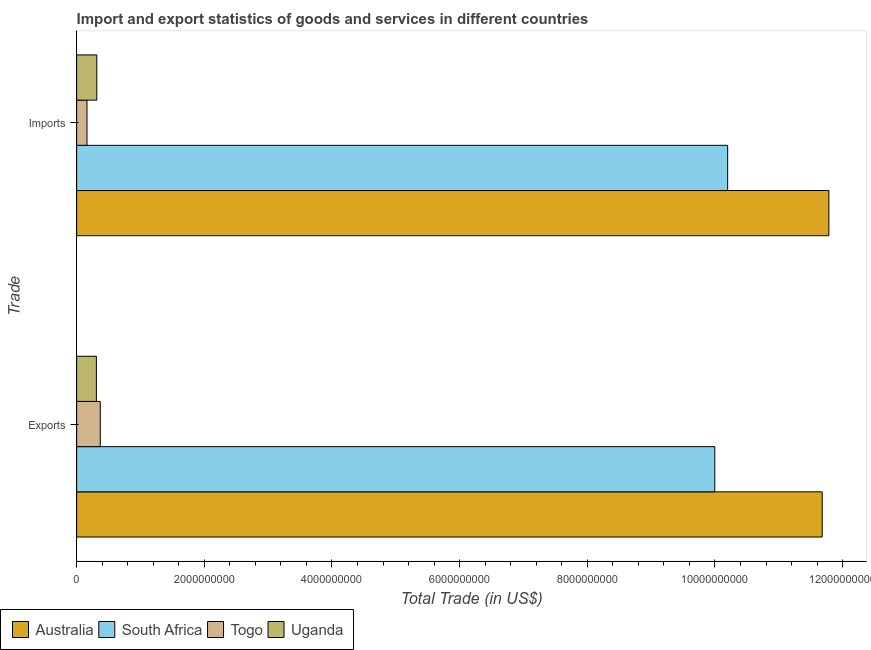How many different coloured bars are there?
Keep it short and to the point. 4. How many groups of bars are there?
Provide a short and direct response. 2. Are the number of bars per tick equal to the number of legend labels?
Offer a very short reply. Yes. Are the number of bars on each tick of the Y-axis equal?
Keep it short and to the point. Yes. How many bars are there on the 1st tick from the bottom?
Your answer should be very brief. 4. What is the label of the 2nd group of bars from the top?
Offer a terse response. Exports. What is the imports of goods and services in South Africa?
Offer a very short reply. 1.02e+1. Across all countries, what is the maximum imports of goods and services?
Your answer should be very brief. 1.18e+1. Across all countries, what is the minimum imports of goods and services?
Give a very brief answer. 1.62e+08. In which country was the imports of goods and services maximum?
Your answer should be compact. Australia. In which country was the export of goods and services minimum?
Provide a short and direct response. Uganda. What is the total export of goods and services in the graph?
Offer a terse response. 2.24e+1. What is the difference between the export of goods and services in Australia and that in South Africa?
Keep it short and to the point. 1.68e+09. What is the difference between the export of goods and services in South Africa and the imports of goods and services in Australia?
Provide a succinct answer. -1.79e+09. What is the average export of goods and services per country?
Offer a terse response. 5.59e+09. What is the difference between the imports of goods and services and export of goods and services in South Africa?
Your answer should be compact. 2.02e+08. What is the ratio of the imports of goods and services in Uganda to that in Togo?
Keep it short and to the point. 1.95. Is the imports of goods and services in Australia less than that in South Africa?
Provide a succinct answer. No. What does the 4th bar from the top in Exports represents?
Ensure brevity in your answer.  Australia. What does the 3rd bar from the bottom in Exports represents?
Your answer should be very brief. Togo. How many bars are there?
Provide a short and direct response. 8. Are all the bars in the graph horizontal?
Offer a terse response. Yes. How many countries are there in the graph?
Offer a terse response. 4. What is the difference between two consecutive major ticks on the X-axis?
Ensure brevity in your answer.  2.00e+09. Does the graph contain any zero values?
Offer a very short reply. No. Does the graph contain grids?
Offer a terse response. No. How many legend labels are there?
Provide a succinct answer. 4. What is the title of the graph?
Ensure brevity in your answer.  Import and export statistics of goods and services in different countries. What is the label or title of the X-axis?
Offer a terse response. Total Trade (in US$). What is the label or title of the Y-axis?
Offer a terse response. Trade. What is the Total Trade (in US$) of Australia in Exports?
Offer a very short reply. 1.17e+1. What is the Total Trade (in US$) of South Africa in Exports?
Give a very brief answer. 1.00e+1. What is the Total Trade (in US$) of Togo in Exports?
Your answer should be compact. 3.70e+08. What is the Total Trade (in US$) in Uganda in Exports?
Make the answer very short. 3.09e+08. What is the Total Trade (in US$) in Australia in Imports?
Provide a short and direct response. 1.18e+1. What is the Total Trade (in US$) in South Africa in Imports?
Give a very brief answer. 1.02e+1. What is the Total Trade (in US$) of Togo in Imports?
Make the answer very short. 1.62e+08. What is the Total Trade (in US$) of Uganda in Imports?
Give a very brief answer. 3.16e+08. Across all Trade, what is the maximum Total Trade (in US$) in Australia?
Give a very brief answer. 1.18e+1. Across all Trade, what is the maximum Total Trade (in US$) of South Africa?
Make the answer very short. 1.02e+1. Across all Trade, what is the maximum Total Trade (in US$) in Togo?
Keep it short and to the point. 3.70e+08. Across all Trade, what is the maximum Total Trade (in US$) in Uganda?
Provide a short and direct response. 3.16e+08. Across all Trade, what is the minimum Total Trade (in US$) of Australia?
Your response must be concise. 1.17e+1. Across all Trade, what is the minimum Total Trade (in US$) in South Africa?
Provide a short and direct response. 1.00e+1. Across all Trade, what is the minimum Total Trade (in US$) of Togo?
Ensure brevity in your answer.  1.62e+08. Across all Trade, what is the minimum Total Trade (in US$) of Uganda?
Your answer should be compact. 3.09e+08. What is the total Total Trade (in US$) of Australia in the graph?
Give a very brief answer. 2.35e+1. What is the total Total Trade (in US$) of South Africa in the graph?
Offer a very short reply. 2.02e+1. What is the total Total Trade (in US$) in Togo in the graph?
Make the answer very short. 5.32e+08. What is the total Total Trade (in US$) in Uganda in the graph?
Offer a terse response. 6.25e+08. What is the difference between the Total Trade (in US$) in Australia in Exports and that in Imports?
Provide a short and direct response. -1.05e+08. What is the difference between the Total Trade (in US$) in South Africa in Exports and that in Imports?
Your response must be concise. -2.02e+08. What is the difference between the Total Trade (in US$) of Togo in Exports and that in Imports?
Your response must be concise. 2.08e+08. What is the difference between the Total Trade (in US$) of Uganda in Exports and that in Imports?
Your answer should be very brief. -6.84e+06. What is the difference between the Total Trade (in US$) in Australia in Exports and the Total Trade (in US$) in South Africa in Imports?
Make the answer very short. 1.48e+09. What is the difference between the Total Trade (in US$) in Australia in Exports and the Total Trade (in US$) in Togo in Imports?
Offer a very short reply. 1.15e+1. What is the difference between the Total Trade (in US$) of Australia in Exports and the Total Trade (in US$) of Uganda in Imports?
Make the answer very short. 1.14e+1. What is the difference between the Total Trade (in US$) of South Africa in Exports and the Total Trade (in US$) of Togo in Imports?
Offer a terse response. 9.84e+09. What is the difference between the Total Trade (in US$) in South Africa in Exports and the Total Trade (in US$) in Uganda in Imports?
Give a very brief answer. 9.68e+09. What is the difference between the Total Trade (in US$) in Togo in Exports and the Total Trade (in US$) in Uganda in Imports?
Offer a terse response. 5.41e+07. What is the average Total Trade (in US$) in Australia per Trade?
Your answer should be compact. 1.17e+1. What is the average Total Trade (in US$) of South Africa per Trade?
Make the answer very short. 1.01e+1. What is the average Total Trade (in US$) of Togo per Trade?
Offer a terse response. 2.66e+08. What is the average Total Trade (in US$) in Uganda per Trade?
Your response must be concise. 3.12e+08. What is the difference between the Total Trade (in US$) in Australia and Total Trade (in US$) in South Africa in Exports?
Make the answer very short. 1.68e+09. What is the difference between the Total Trade (in US$) of Australia and Total Trade (in US$) of Togo in Exports?
Offer a very short reply. 1.13e+1. What is the difference between the Total Trade (in US$) in Australia and Total Trade (in US$) in Uganda in Exports?
Your answer should be very brief. 1.14e+1. What is the difference between the Total Trade (in US$) in South Africa and Total Trade (in US$) in Togo in Exports?
Make the answer very short. 9.63e+09. What is the difference between the Total Trade (in US$) in South Africa and Total Trade (in US$) in Uganda in Exports?
Your answer should be compact. 9.69e+09. What is the difference between the Total Trade (in US$) of Togo and Total Trade (in US$) of Uganda in Exports?
Give a very brief answer. 6.10e+07. What is the difference between the Total Trade (in US$) in Australia and Total Trade (in US$) in South Africa in Imports?
Ensure brevity in your answer.  1.59e+09. What is the difference between the Total Trade (in US$) of Australia and Total Trade (in US$) of Togo in Imports?
Your response must be concise. 1.16e+1. What is the difference between the Total Trade (in US$) of Australia and Total Trade (in US$) of Uganda in Imports?
Offer a very short reply. 1.15e+1. What is the difference between the Total Trade (in US$) in South Africa and Total Trade (in US$) in Togo in Imports?
Your answer should be very brief. 1.00e+1. What is the difference between the Total Trade (in US$) in South Africa and Total Trade (in US$) in Uganda in Imports?
Offer a very short reply. 9.88e+09. What is the difference between the Total Trade (in US$) of Togo and Total Trade (in US$) of Uganda in Imports?
Provide a short and direct response. -1.54e+08. What is the ratio of the Total Trade (in US$) of Australia in Exports to that in Imports?
Ensure brevity in your answer.  0.99. What is the ratio of the Total Trade (in US$) in South Africa in Exports to that in Imports?
Make the answer very short. 0.98. What is the ratio of the Total Trade (in US$) of Togo in Exports to that in Imports?
Make the answer very short. 2.29. What is the ratio of the Total Trade (in US$) of Uganda in Exports to that in Imports?
Make the answer very short. 0.98. What is the difference between the highest and the second highest Total Trade (in US$) of Australia?
Provide a succinct answer. 1.05e+08. What is the difference between the highest and the second highest Total Trade (in US$) of South Africa?
Provide a succinct answer. 2.02e+08. What is the difference between the highest and the second highest Total Trade (in US$) of Togo?
Your answer should be compact. 2.08e+08. What is the difference between the highest and the second highest Total Trade (in US$) of Uganda?
Offer a terse response. 6.84e+06. What is the difference between the highest and the lowest Total Trade (in US$) in Australia?
Give a very brief answer. 1.05e+08. What is the difference between the highest and the lowest Total Trade (in US$) of South Africa?
Offer a very short reply. 2.02e+08. What is the difference between the highest and the lowest Total Trade (in US$) of Togo?
Offer a terse response. 2.08e+08. What is the difference between the highest and the lowest Total Trade (in US$) of Uganda?
Your response must be concise. 6.84e+06. 